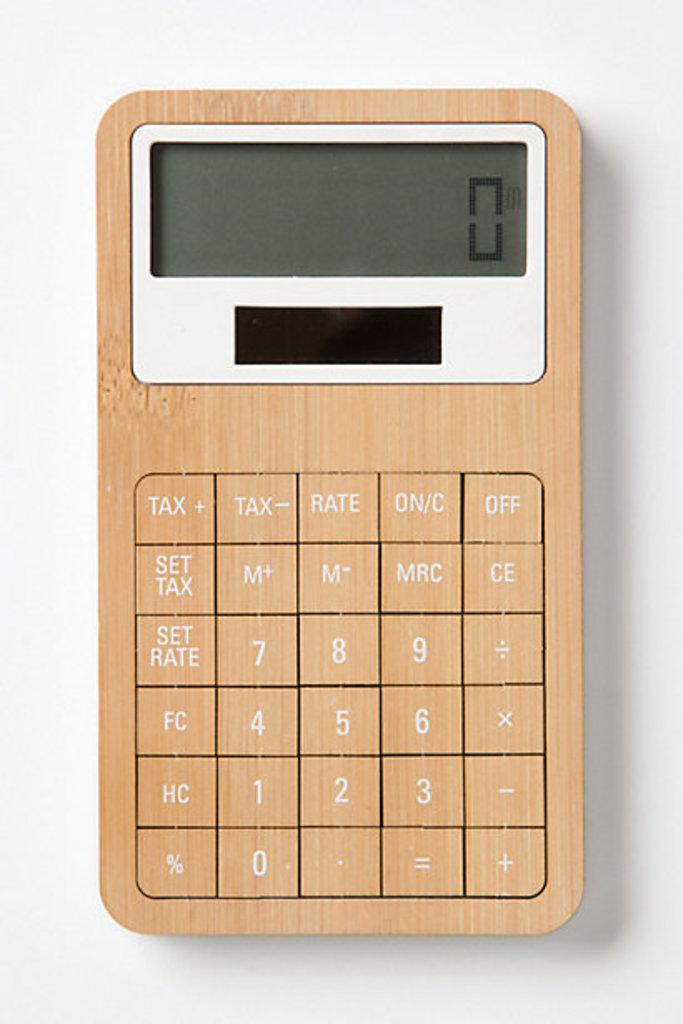Provide a one-sentence caption for the provided image. The calculator has special function buttons for tax calculations. 